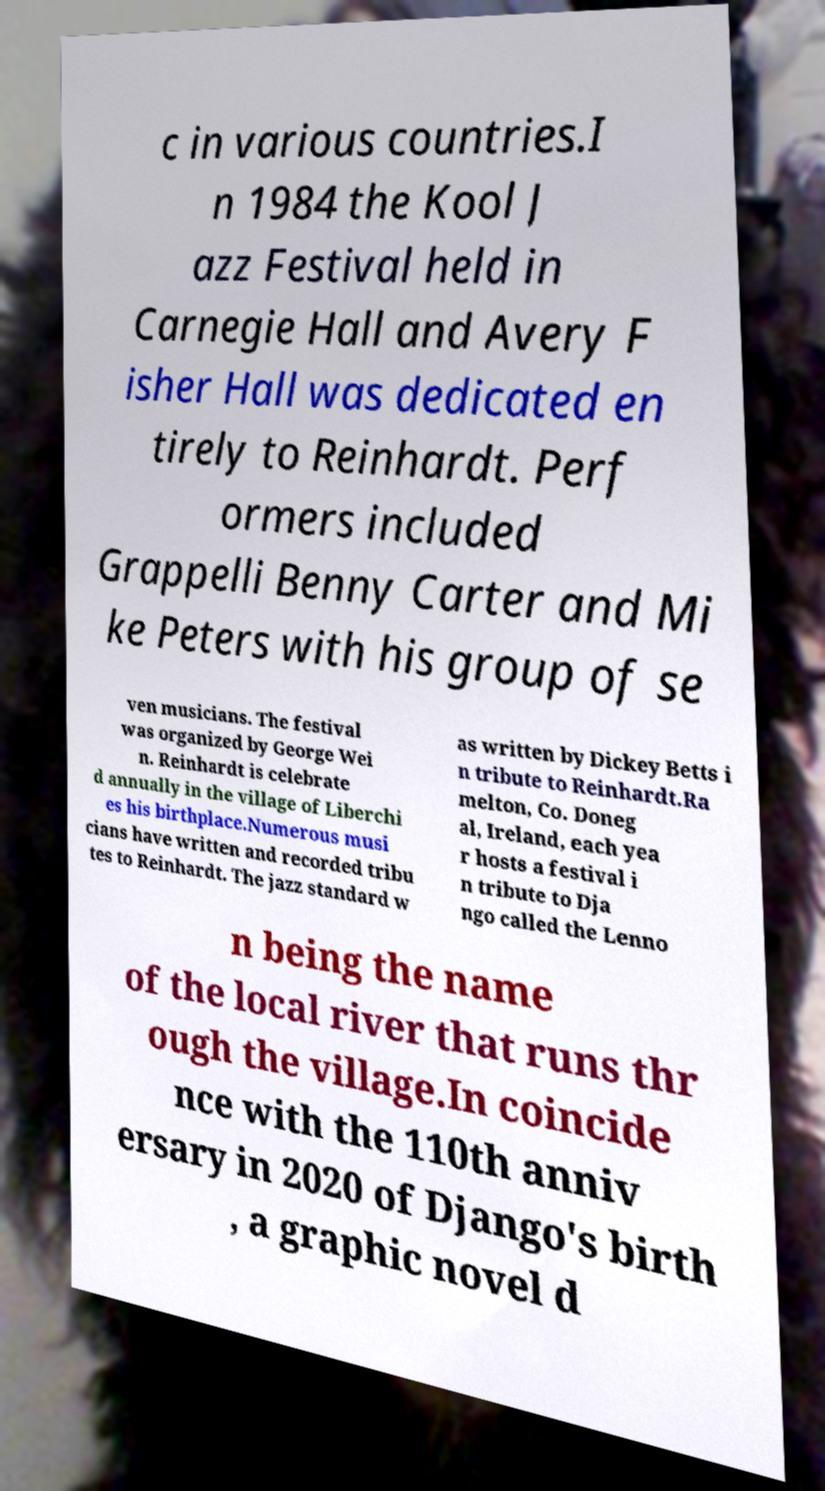Could you extract and type out the text from this image? c in various countries.I n 1984 the Kool J azz Festival held in Carnegie Hall and Avery F isher Hall was dedicated en tirely to Reinhardt. Perf ormers included Grappelli Benny Carter and Mi ke Peters with his group of se ven musicians. The festival was organized by George Wei n. Reinhardt is celebrate d annually in the village of Liberchi es his birthplace.Numerous musi cians have written and recorded tribu tes to Reinhardt. The jazz standard w as written by Dickey Betts i n tribute to Reinhardt.Ra melton, Co. Doneg al, Ireland, each yea r hosts a festival i n tribute to Dja ngo called the Lenno n being the name of the local river that runs thr ough the village.In coincide nce with the 110th anniv ersary in 2020 of Django's birth , a graphic novel d 